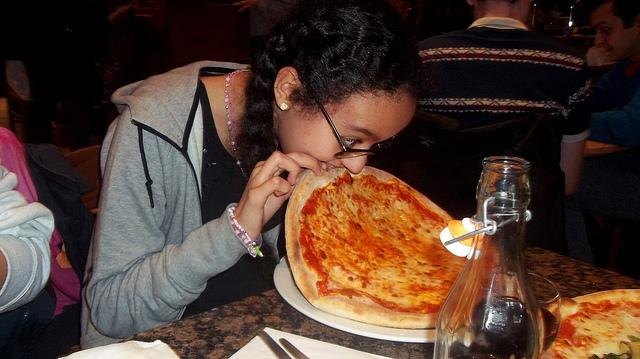What would most people do first before biting their pizza? Please explain your reasoning. slice it. Pizza is always served in slices. 